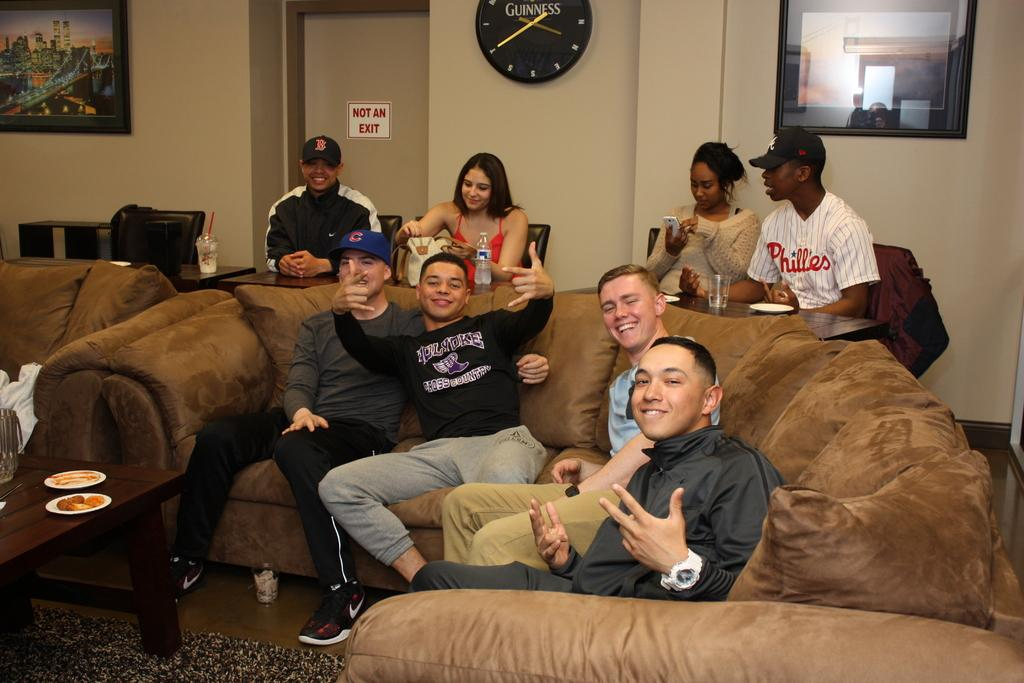Provide a one-sentence caption for the provided image. a not an exit sign that is on a door. 